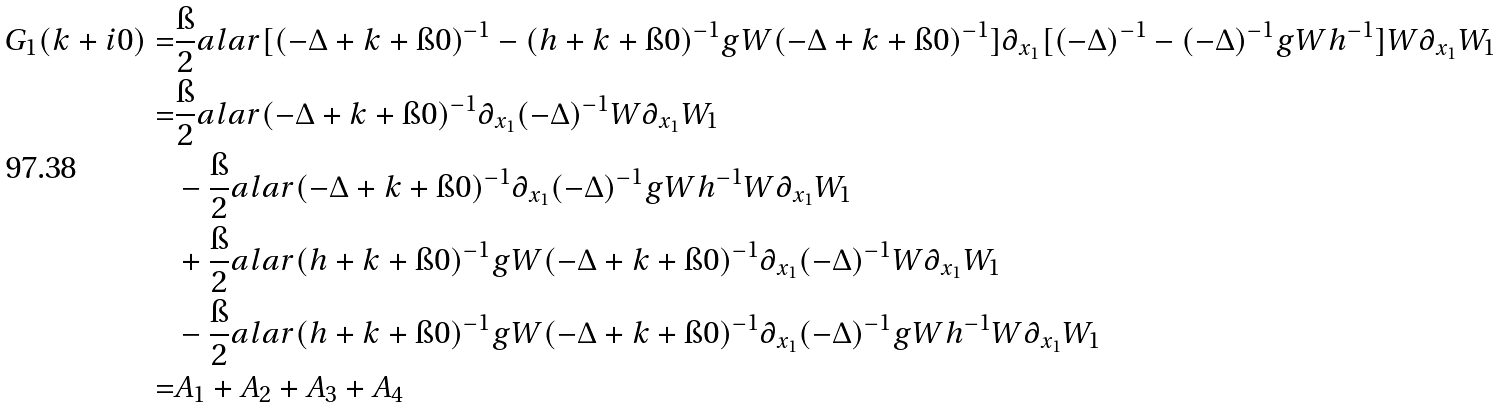Convert formula to latex. <formula><loc_0><loc_0><loc_500><loc_500>G _ { 1 } ( k + i 0 ) = & \frac { \i } { 2 } a l a r { [ ( - \Delta + k + \i 0 ) ^ { - 1 } - ( h + k + \i 0 ) ^ { - 1 } g W ( - \Delta + k + \i 0 ) ^ { - 1 } ] \partial _ { x _ { 1 } } [ ( - \Delta ) ^ { - 1 } - ( - \Delta ) ^ { - 1 } g W h ^ { - 1 } ] W } { \partial _ { x _ { 1 } } W _ { 1 } } \\ = & \frac { \i } { 2 } a l a r { ( - \Delta + k + \i 0 ) ^ { - 1 } \partial _ { x _ { 1 } } ( - \Delta ) ^ { - 1 } W } { \partial _ { x _ { 1 } } W _ { 1 } } \\ & - \frac { \i } { 2 } a l a r { ( - \Delta + k + \i 0 ) ^ { - 1 } \partial _ { x _ { 1 } } ( - \Delta ) ^ { - 1 } g W h ^ { - 1 } W } { \partial _ { x _ { 1 } } W _ { 1 } } \\ & + \frac { \i } { 2 } a l a r { ( h + k + \i 0 ) ^ { - 1 } g W ( - \Delta + k + \i 0 ) ^ { - 1 } \partial _ { x _ { 1 } } ( - \Delta ) ^ { - 1 } W } { \partial _ { x _ { 1 } } W _ { 1 } } \\ & - \frac { \i } { 2 } a l a r { ( h + k + \i 0 ) ^ { - 1 } g W ( - \Delta + k + \i 0 ) ^ { - 1 } \partial _ { x _ { 1 } } ( - \Delta ) ^ { - 1 } g W h ^ { - 1 } W } { \partial _ { x _ { 1 } } W _ { 1 } } \\ = & A _ { 1 } + A _ { 2 } + A _ { 3 } + A _ { 4 }</formula> 